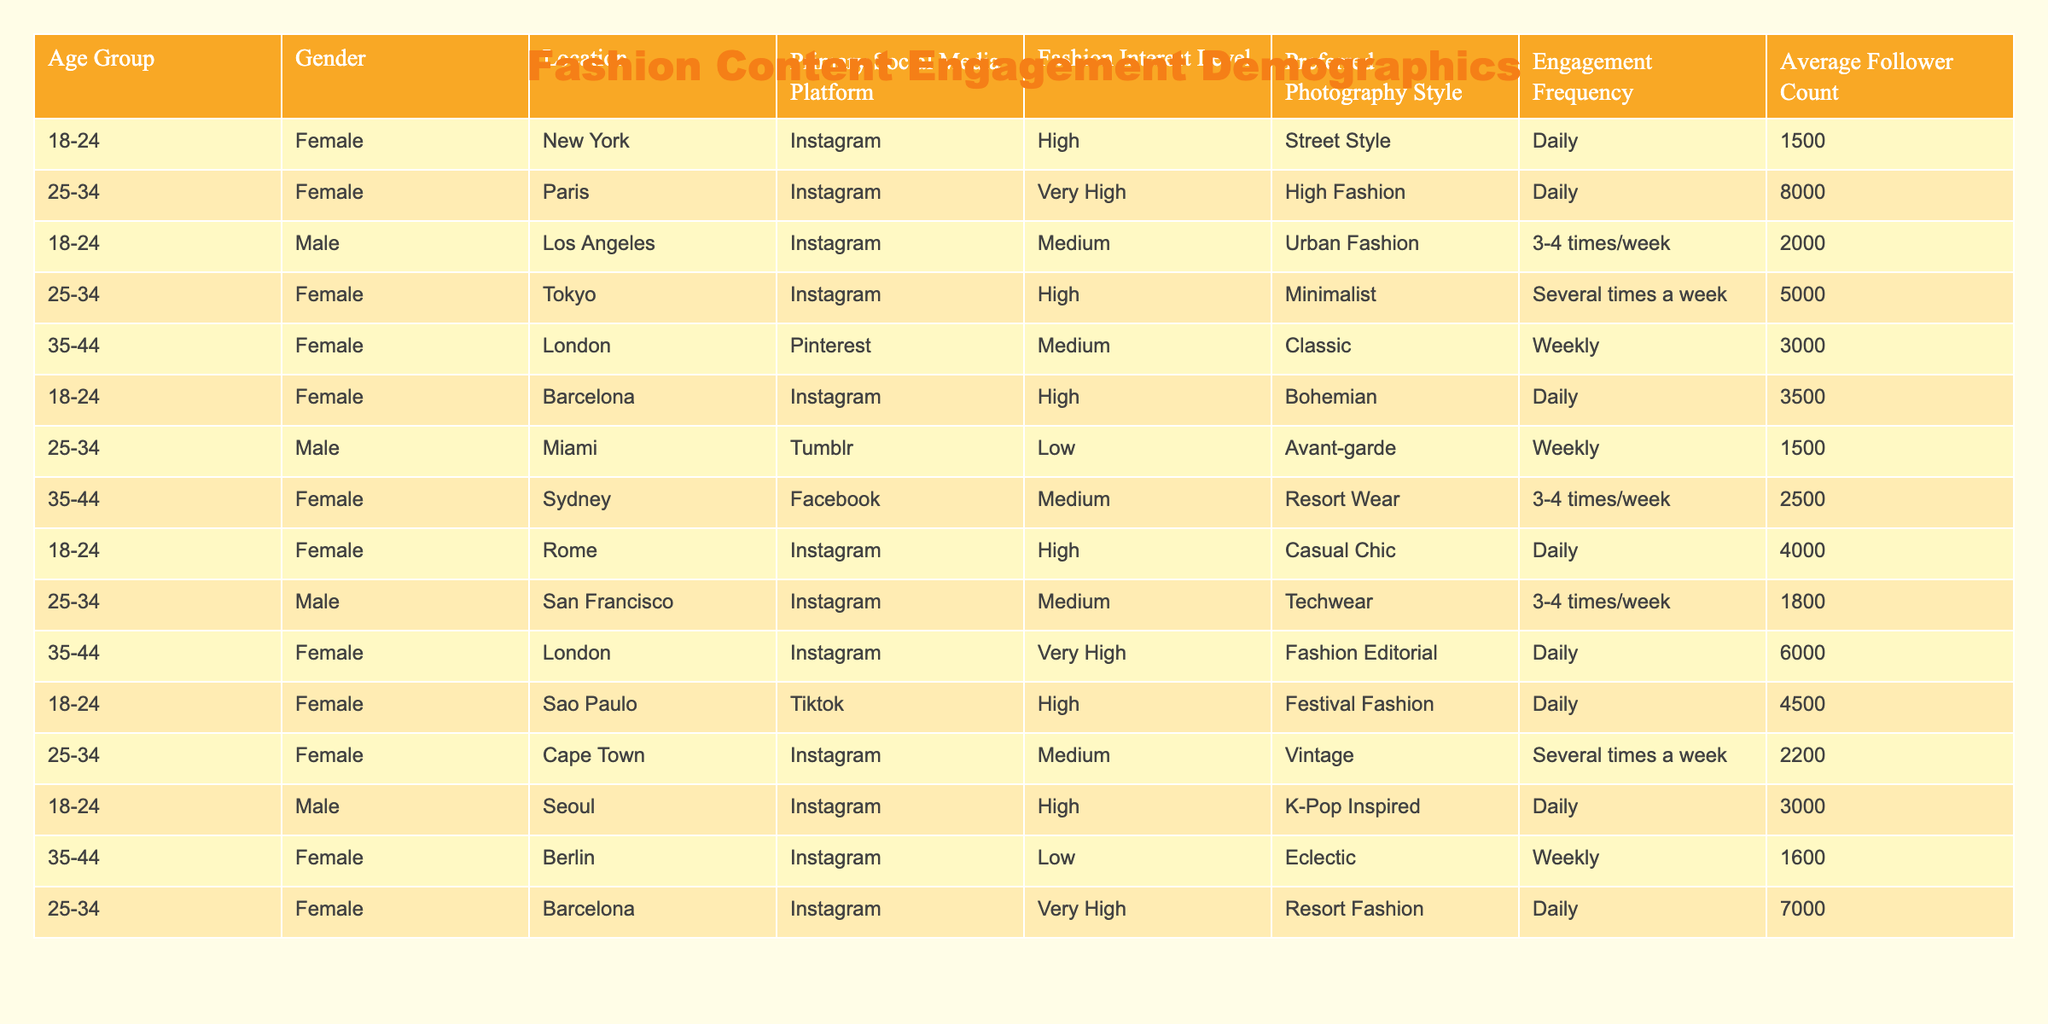What is the primary social media platform used by female users aged 25-34 in Paris? The table shows that in Paris, the primary social media platform for female users aged 25-34 is Instagram.
Answer: Instagram How many users have a very high fashion interest level? By inspecting the table, we can see that the users from Paris, London, and Barcelona all have a very high fashion interest level. The total number of these users is three.
Answer: 3 What is the average follower count of male users in Los Angeles and Seoul combined? The average follower count of male users is calculated by first identifying the individual counts: Los Angeles has 2000 followers and Seoul has 3000 followers. Summing these gives us 5000 followers. To find the average, divide 5000 by 2 (the number of users), resulting in 2500.
Answer: 2500 Are there any users from Sydney who engage with fashion content on Instagram? Looking at the location column, the table indicates that the female user from Sydney engages primarily on Facebook, not Instagram. Therefore, the answer is no.
Answer: No Which location has the highest average follower count among female users interested in Resort Fashion? The users engaged with Resort Fashion are from Sydney and Barcelona. Sydney's user has 2500 followers, while the user from Barcelona has 7000 followers. Comparing these two shows that Barcelona has the higher average follower count of 7000.
Answer: Barcelona Does any male user have a low fashion interest level? Scanning the table, the only male user with a low fashion interest level is from Miami. Thus, the answer is yes.
Answer: Yes What is the total number of daily engagement users among females aged 18-24? The daily engagement users among females aged 18-24 are from New York, Barcelona, and Rome. Their follower counts are 1500, 3500, and 4000 respectively. Totaling these gives 1500 + 3500 + 4000 = 9000.
Answer: 9000 Is the age group with the highest fashion interest level predominantly female? By evaluating the table, we see that both age groups (18-24 and 25-34) have a majority of female users with high to very high fashion interest levels, thus confirming that the highest interest level is predominantly female.
Answer: Yes What is the gender distribution of users engaging with fashion content in picturesque areas? Analyzing the table shows that there are 11 female users and 7 male users, leading to a predominantly female distribution among those engaging with fashion content.
Answer: Predominantly female 